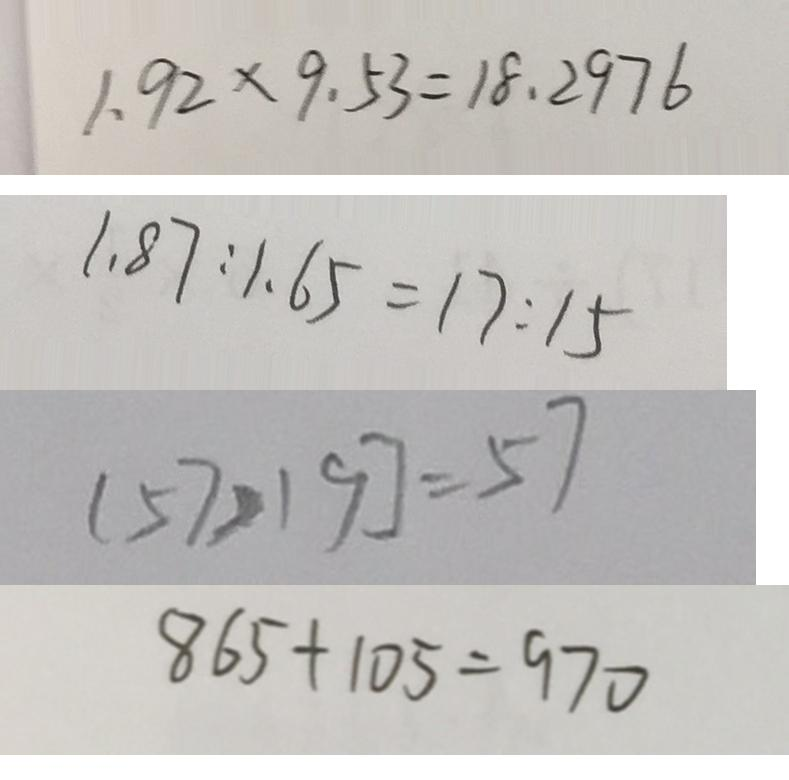Convert formula to latex. <formula><loc_0><loc_0><loc_500><loc_500>1 . 9 2 \times 9 . 5 3 = 1 8 . 2 9 7 6 
 1 . 8 7 : 1 . 6 5 = 1 7 : 1 5 
 [ 5 7 > 1 9 ] = 5 7 
 8 6 5 + 1 0 5 = 9 7 0</formula> 